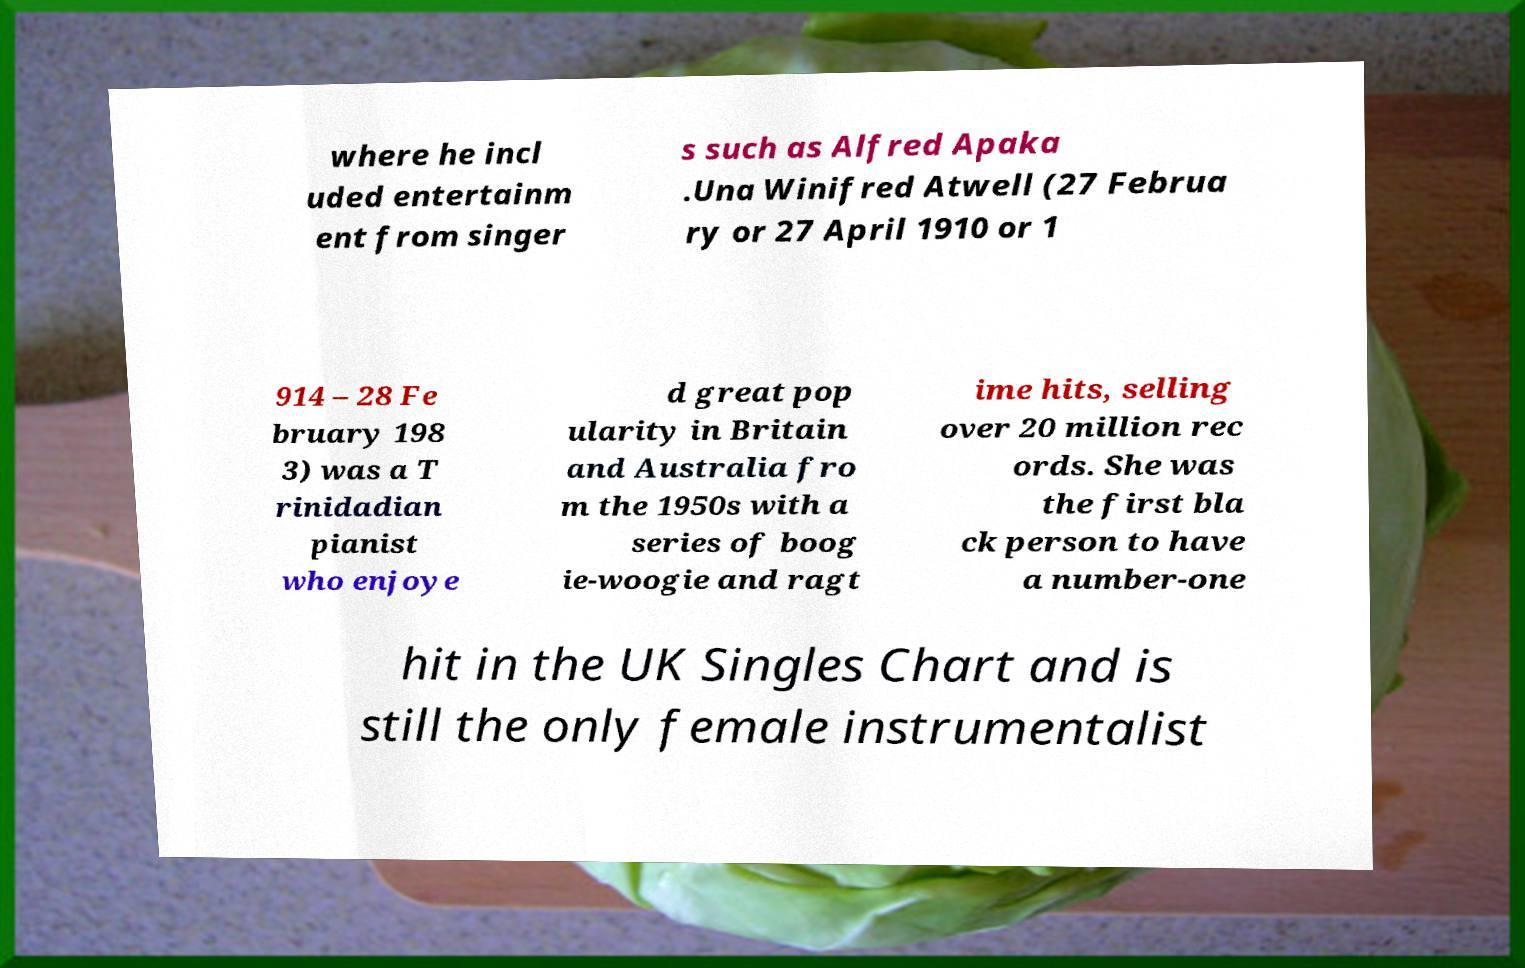Could you assist in decoding the text presented in this image and type it out clearly? where he incl uded entertainm ent from singer s such as Alfred Apaka .Una Winifred Atwell (27 Februa ry or 27 April 1910 or 1 914 – 28 Fe bruary 198 3) was a T rinidadian pianist who enjoye d great pop ularity in Britain and Australia fro m the 1950s with a series of boog ie-woogie and ragt ime hits, selling over 20 million rec ords. She was the first bla ck person to have a number-one hit in the UK Singles Chart and is still the only female instrumentalist 